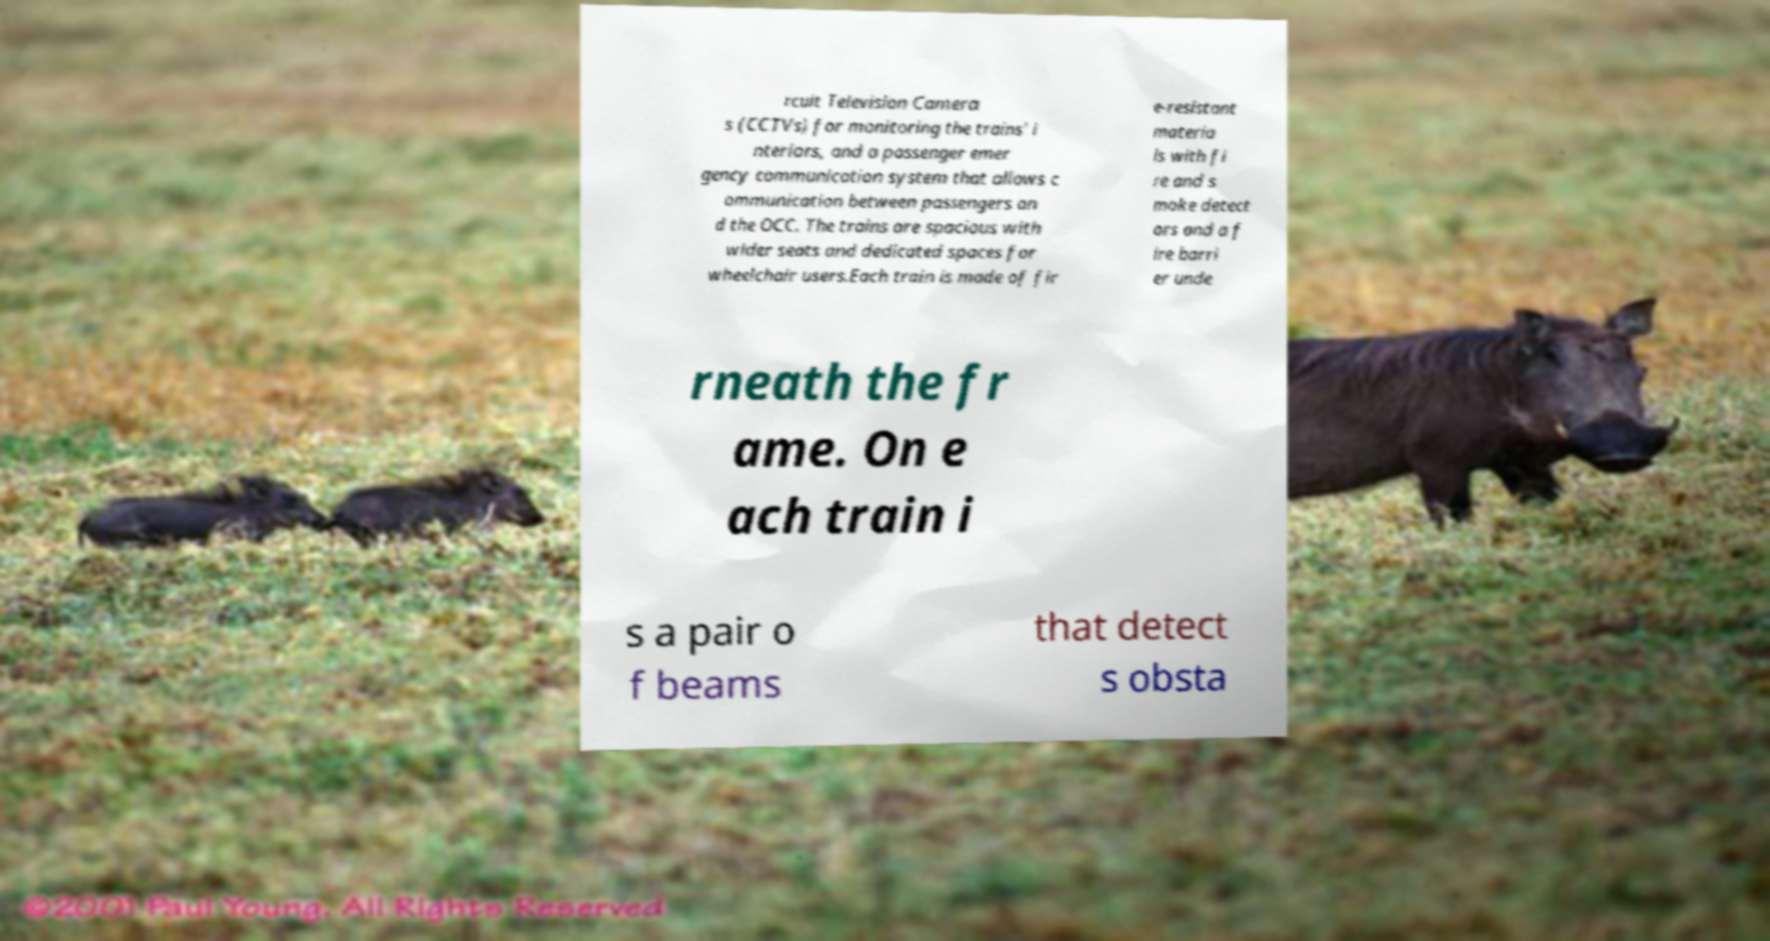I need the written content from this picture converted into text. Can you do that? rcuit Television Camera s (CCTVs) for monitoring the trains' i nteriors, and a passenger emer gency communication system that allows c ommunication between passengers an d the OCC. The trains are spacious with wider seats and dedicated spaces for wheelchair users.Each train is made of fir e-resistant materia ls with fi re and s moke detect ors and a f ire barri er unde rneath the fr ame. On e ach train i s a pair o f beams that detect s obsta 